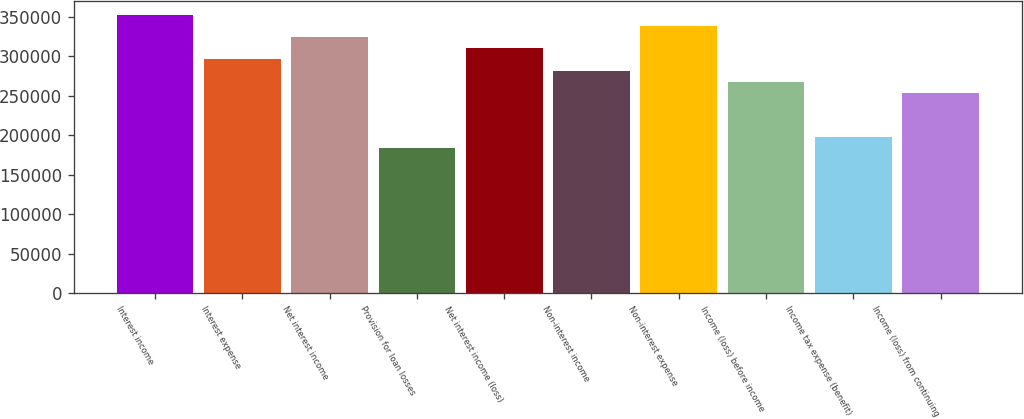Convert chart to OTSL. <chart><loc_0><loc_0><loc_500><loc_500><bar_chart><fcel>Interest income<fcel>Interest expense<fcel>Net interest income<fcel>Provision for loan losses<fcel>Net interest income (loss)<fcel>Non-interest income<fcel>Non-interest expense<fcel>Income (loss) before income<fcel>Income tax expense (benefit)<fcel>Income (loss) from continuing<nl><fcel>352604<fcel>296187<fcel>324395<fcel>183354<fcel>310291<fcel>282083<fcel>338500<fcel>267979<fcel>197458<fcel>253875<nl></chart> 